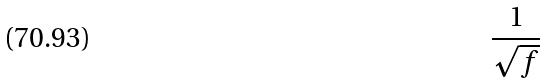<formula> <loc_0><loc_0><loc_500><loc_500>\frac { 1 } { \sqrt { f } }</formula> 